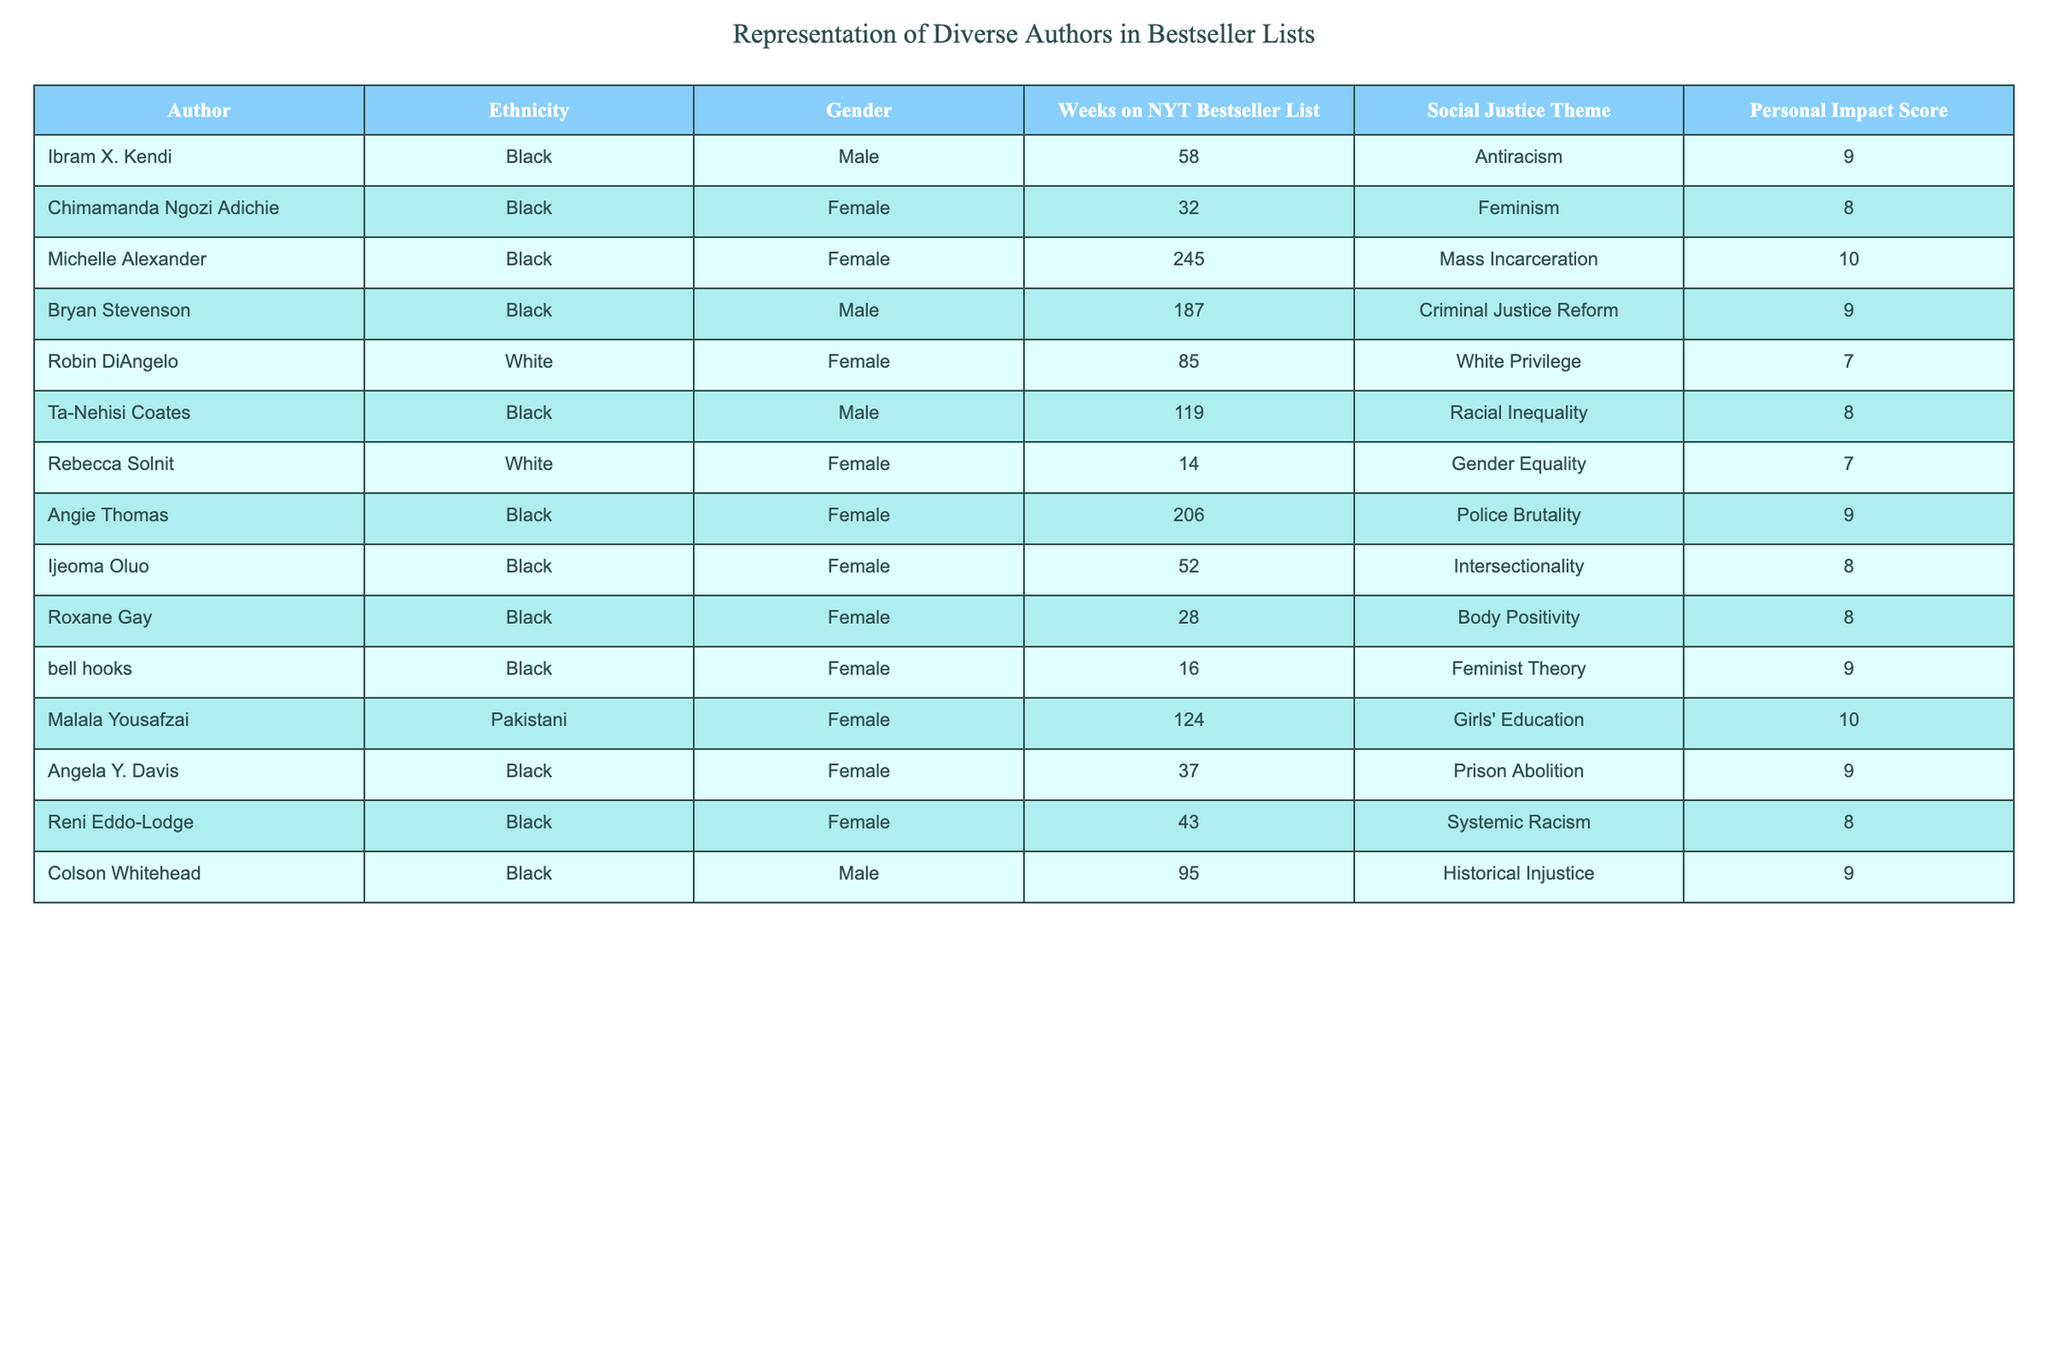What is the ethnicity of Michelle Alexander? The table lists authors along with their ethnicities. Looking for Michelle Alexander in the table reveals that her ethnicity is Black.
Answer: Black Which author has the highest Personal Impact Score? By examining the Personal Impact Scores in the table, I see that Michelle Alexander has the highest score of 10.
Answer: Michelle Alexander How many female authors are in the table? The authors column can be filtered for female authors. Counting them, we find a total of 7 female authors listed in the table.
Answer: 7 What is the total number of weeks that Ibram X. Kendi spent on the NYT Bestseller List? Referring to the table, I see that Ibram X. Kendi spent 58 weeks on the NYT Bestseller List.
Answer: 58 weeks What is the average Personal Impact Score for white authors? In the table, the Personal Impact Scores for white authors (Robin DiAngelo and Rebecca Solnit) are 7 and 7 respectively. The average is calculated as (7 + 7) / 2 = 7.
Answer: 7 Did any authors focus on "Girls' Education"? Checking the Social Justice Theme column, I find that Malala Yousafzai is the only author who focuses on "Girls' Education." Therefore, the answer is yes.
Answer: Yes How many weeks on the NYT Bestseller List did authors centered on "Mass Incarceration" and "Police Brutality" combine? The weeks on the NYT Bestseller List for Michelle Alexander (245 weeks) and Angie Thomas (206 weeks) add up to 245 + 206 = 451 weeks.
Answer: 451 weeks Which gender has more representation among authors that address "Racial Inequality"? Ta-Nehisi Coates, who is male, is the only author addressing "Racial Inequality." Therefore, males have more representation in this category.
Answer: Male What percentage of the authors listed have a Personal Impact Score of 8 or above? Counting the authors with scores of 8 or above (6 authors: Michelle Alexander, Bryan Stevenson, Malala Yousafzai, Angela Y. Davis, Ijeoma Oluo, and bell hooks) gives us 6 out of 14 authors. The percentage is (6/14) * 100 ≈ 42.86%.
Answer: Approximately 42.86% What is the difference in weeks on the NYT Bestseller List between the author with the most weeks and the author with the least weeks? The author with the most weeks is Michelle Alexander (245 weeks) and the one with the least is Rebecca Solnit (14 weeks). The difference is 245 - 14 = 231 weeks.
Answer: 231 weeks 